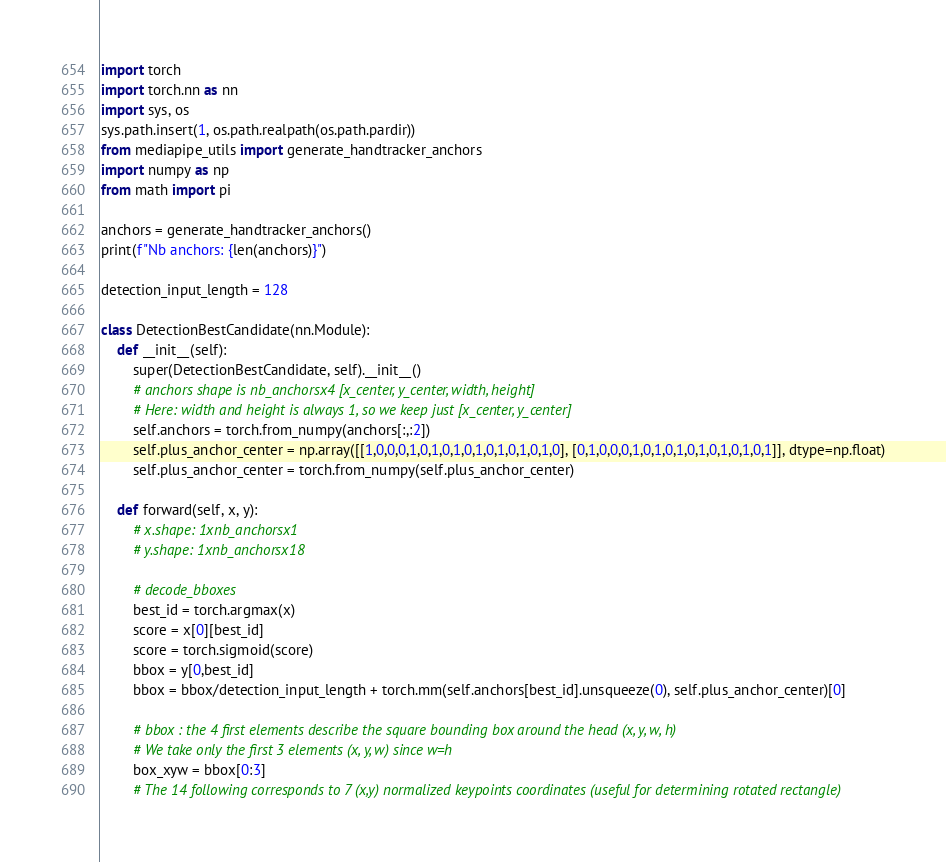<code> <loc_0><loc_0><loc_500><loc_500><_Python_>import torch
import torch.nn as nn
import sys, os
sys.path.insert(1, os.path.realpath(os.path.pardir))
from mediapipe_utils import generate_handtracker_anchors
import numpy as np
from math import pi

anchors = generate_handtracker_anchors()
print(f"Nb anchors: {len(anchors)}")

detection_input_length = 128

class DetectionBestCandidate(nn.Module):
    def __init__(self):
        super(DetectionBestCandidate, self).__init__()
        # anchors shape is nb_anchorsx4 [x_center, y_center, width, height]
        # Here: width and height is always 1, so we keep just [x_center, y_center]
        self.anchors = torch.from_numpy(anchors[:,:2])
        self.plus_anchor_center = np.array([[1,0,0,0,1,0,1,0,1,0,1,0,1,0,1,0,1,0], [0,1,0,0,0,1,0,1,0,1,0,1,0,1,0,1,0,1]], dtype=np.float)
        self.plus_anchor_center = torch.from_numpy(self.plus_anchor_center)

    def forward(self, x, y):
        # x.shape: 1xnb_anchorsx1
        # y.shape: 1xnb_anchorsx18

        # decode_bboxes
        best_id = torch.argmax(x)
        score = x[0][best_id]
        score = torch.sigmoid(score) 
        bbox = y[0,best_id]
        bbox = bbox/detection_input_length + torch.mm(self.anchors[best_id].unsqueeze(0), self.plus_anchor_center)[0]

        # bbox : the 4 first elements describe the square bounding box around the head (x, y, w, h)
        # We take only the first 3 elements (x, y, w) since w=h
        box_xyw = bbox[0:3]
        # The 14 following corresponds to 7 (x,y) normalized keypoints coordinates (useful for determining rotated rectangle)</code> 